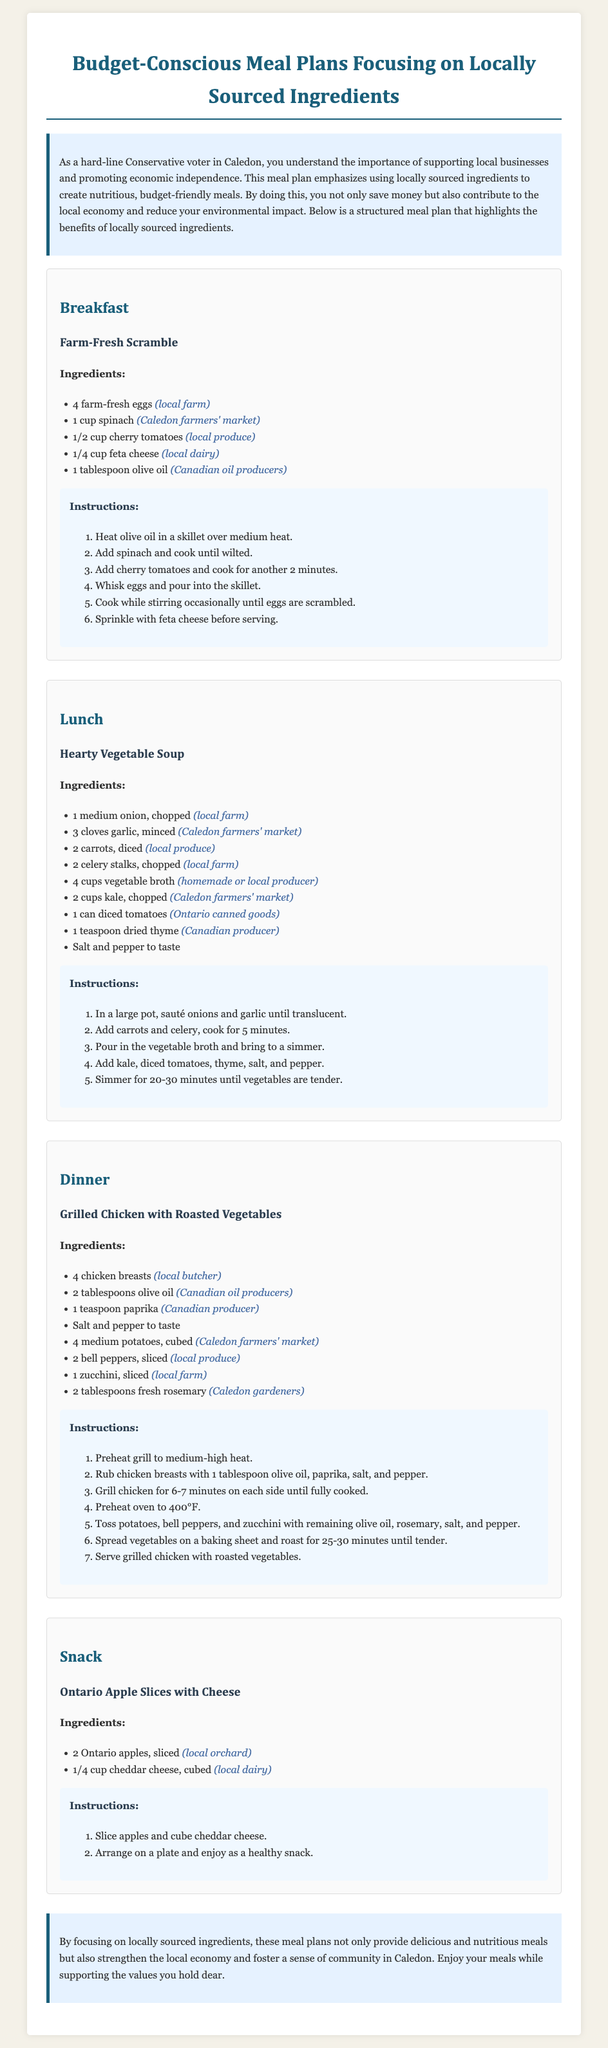What is the title of the document? The title is prominently displayed at the top of the document.
Answer: Budget-Conscious Meal Plans Focusing on Locally Sourced Ingredients How many eggs are used in the breakfast recipe? The breakfast recipe specifies the number of eggs in the ingredients section.
Answer: 4 farm-fresh eggs What type of soup is included in the lunch meal? The lunch meal section clearly states the name of the soup.
Answer: Hearty Vegetable Soup Which local ingredient is mentioned in the dinner recipe for chicken? The dinner recipe lists specific local sources for chicken in the ingredients.
Answer: local butcher What is the main vegetable used in the Hearty Vegetable Soup? The soup ingredients include various vegetables, and the main ones can be inferred from the list.
Answer: kale How many chicken breasts are used in the dinner recipe? The dinner meal ingredients indicate the quantity of chicken breasts required.
Answer: 4 chicken breasts What type of cheese is paired with the Ontario apples in the snack? The snack section provides specific details about the type of cheese used.
Answer: cheddar cheese What is the first ingredient listed for the Farm-Fresh Scramble? The ingredients section for the breakfast meal outlines them in order.
Answer: 4 farm-fresh eggs Which meal includes spinach as an ingredient? The breakfast recipe contains spinach in its list of ingredients.
Answer: Breakfast 